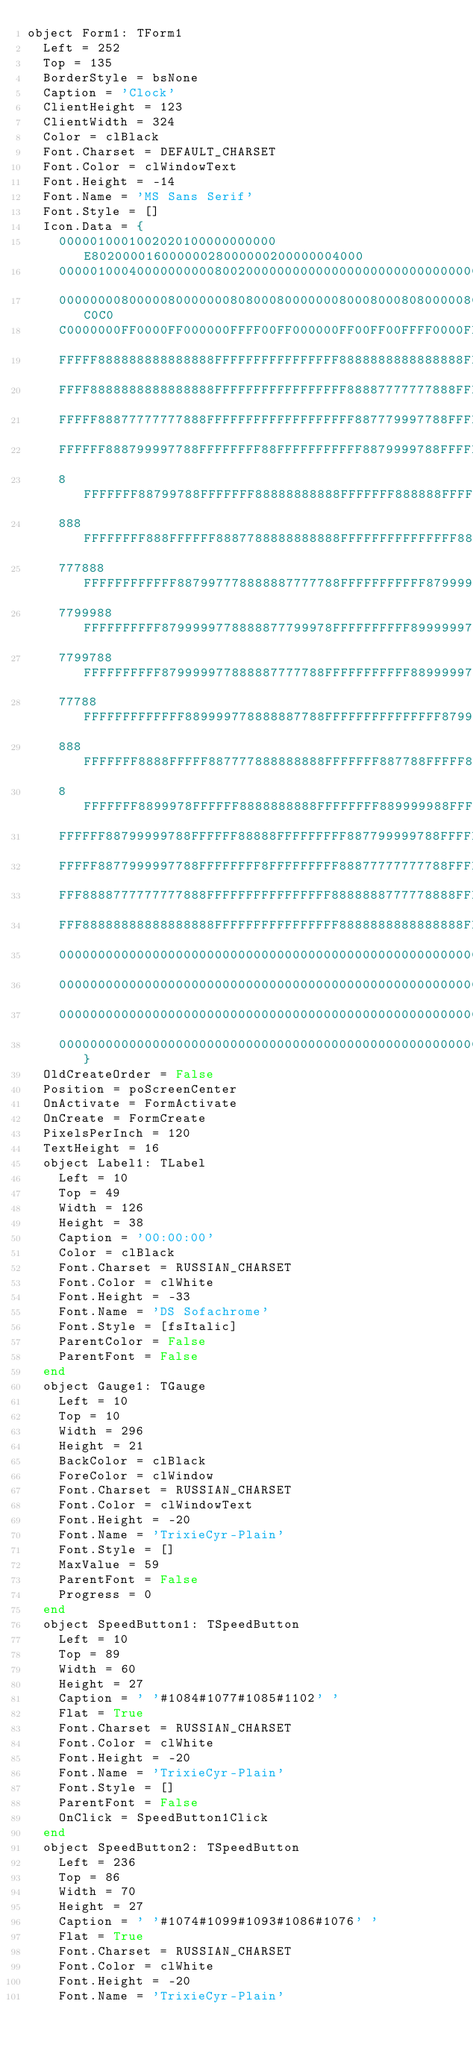Convert code to text. <code><loc_0><loc_0><loc_500><loc_500><_Pascal_>object Form1: TForm1
  Left = 252
  Top = 135
  BorderStyle = bsNone
  Caption = 'Clock'
  ClientHeight = 123
  ClientWidth = 324
  Color = clBlack
  Font.Charset = DEFAULT_CHARSET
  Font.Color = clWindowText
  Font.Height = -14
  Font.Name = 'MS Sans Serif'
  Font.Style = []
  Icon.Data = {
    0000010001002020100000000000E80200001600000028000000200000004000
    0000010004000000000080020000000000000000000000000000000000000000
    000000008000008000000080800080000000800080008080000080808000C0C0
    C0000000FF0000FF000000FFFF00FF000000FF00FF00FFFF0000FFFFFF00FFFF
    FFFFF888888888888888FFFFFFFFFFFFFFFF8888888888888888FFFFFFFFFFFF
    FFFF8888888888888888FFFFFFFFFFFFFFFFF88887777777888FFFFFFFFFFFFF
    FFFFF88877777777888FFFFFFFFFFFFFFFFFFF887779997788FFFFFFFFFFFFFF
    FFFFFF888799997788FFFFFFFF88FFFFFFFFFFF8879999788FFFFFFF8888F888
    8FFFFFFF88799788FFFFFFF88888888888FFFFFFF888888FFFFFF88888888888
    888FFFFFFFF888FFFFFF8887788888888888FFFFFFFFFFFFFFF8887778888888
    777888FFFFFFFFFFFF887997778888887777788FFFFFFFFFFF87999977888887
    7799988FFFFFFFFFF8799999778888877799978FFFFFFFFFF899999977888887
    7799788FFFFFFFFFF879999977888887777788FFFFFFFFFFF889999977888887
    77788FFFFFFFFFFFFF889999778888887788FFFFFFFFFFFFFFF8799777888888
    888FFFFFFF8888FFFFF887777888888888FFFFFFF887788FFFFF887778888888
    8FFFFFFF8899978FFFFFF8888888888FFFFFFFF889999988FFFFFF888888FFFF
    FFFFFF88799999788FFFFFF88888FFFFFFFFF887799999788FFFFFFF8888FFFF
    FFFFF8877999997788FFFFFFFF8FFFFFFFFF88877777777788FFFFFFFFFFFFFF
    FFF8888777777777888FFFFFFFFFFFFFFFF8888888777778888FFFFFFFFFFFFF
    FFF88888888888888888FFFFFFFFFFFFFFFF8888888888888888FFFFFFFF0000
    0000000000000000000000000000000000000000000000000000000000000000
    0000000000000000000000000000000000000000000000000000000000000000
    0000000000000000000000000000000000000000000000000000000000000000
    000000000000000000000000000000000000000000000000000000000000}
  OldCreateOrder = False
  Position = poScreenCenter
  OnActivate = FormActivate
  OnCreate = FormCreate
  PixelsPerInch = 120
  TextHeight = 16
  object Label1: TLabel
    Left = 10
    Top = 49
    Width = 126
    Height = 38
    Caption = '00:00:00'
    Color = clBlack
    Font.Charset = RUSSIAN_CHARSET
    Font.Color = clWhite
    Font.Height = -33
    Font.Name = 'DS Sofachrome'
    Font.Style = [fsItalic]
    ParentColor = False
    ParentFont = False
  end
  object Gauge1: TGauge
    Left = 10
    Top = 10
    Width = 296
    Height = 21
    BackColor = clBlack
    ForeColor = clWindow
    Font.Charset = RUSSIAN_CHARSET
    Font.Color = clWindowText
    Font.Height = -20
    Font.Name = 'TrixieCyr-Plain'
    Font.Style = []
    MaxValue = 59
    ParentFont = False
    Progress = 0
  end
  object SpeedButton1: TSpeedButton
    Left = 10
    Top = 89
    Width = 60
    Height = 27
    Caption = ' '#1084#1077#1085#1102' '
    Flat = True
    Font.Charset = RUSSIAN_CHARSET
    Font.Color = clWhite
    Font.Height = -20
    Font.Name = 'TrixieCyr-Plain'
    Font.Style = []
    ParentFont = False
    OnClick = SpeedButton1Click
  end
  object SpeedButton2: TSpeedButton
    Left = 236
    Top = 86
    Width = 70
    Height = 27
    Caption = ' '#1074#1099#1093#1086#1076' '
    Flat = True
    Font.Charset = RUSSIAN_CHARSET
    Font.Color = clWhite
    Font.Height = -20
    Font.Name = 'TrixieCyr-Plain'</code> 